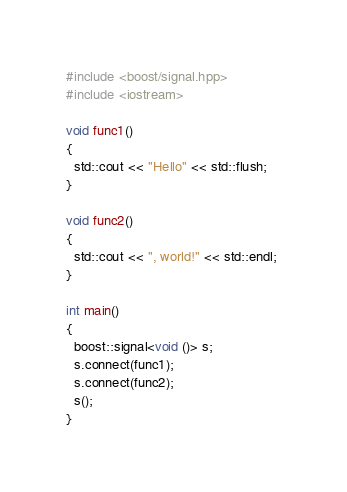<code> <loc_0><loc_0><loc_500><loc_500><_C++_>#include <boost/signal.hpp> 
#include <iostream> 

void func1() 
{ 
  std::cout << "Hello" << std::flush; 
} 

void func2() 
{ 
  std::cout << ", world!" << std::endl; 
} 

int main() 
{ 
  boost::signal<void ()> s; 
  s.connect(func1); 
  s.connect(func2); 
  s(); 
} </code> 